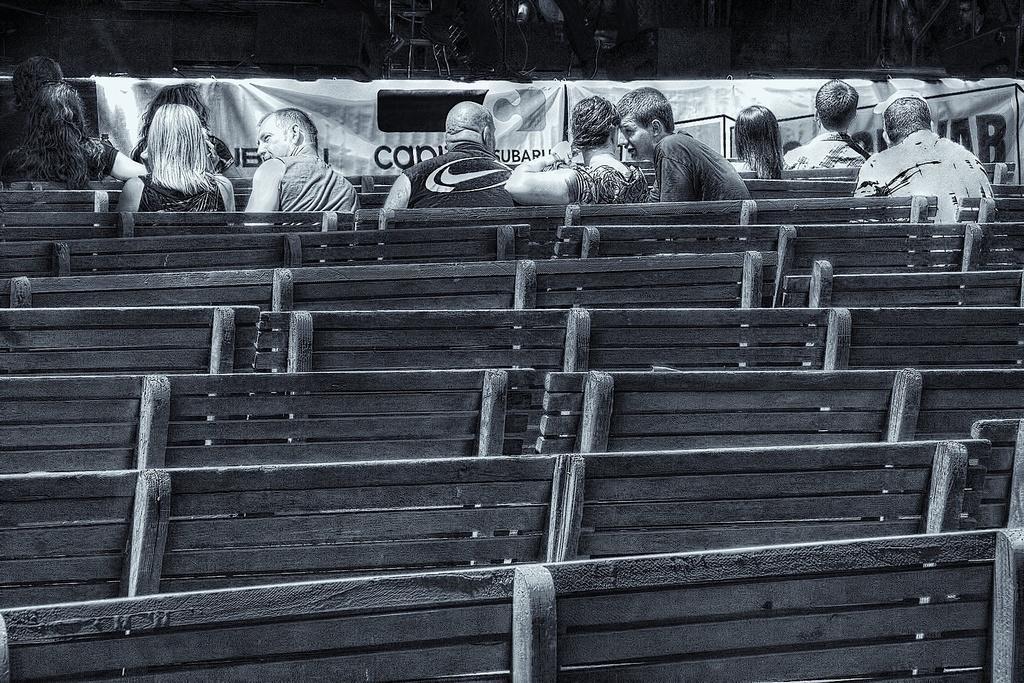In one or two sentences, can you explain what this image depicts? In this picture we can see a group of people sitting on benches and in front of them we can see banners and some objects. 